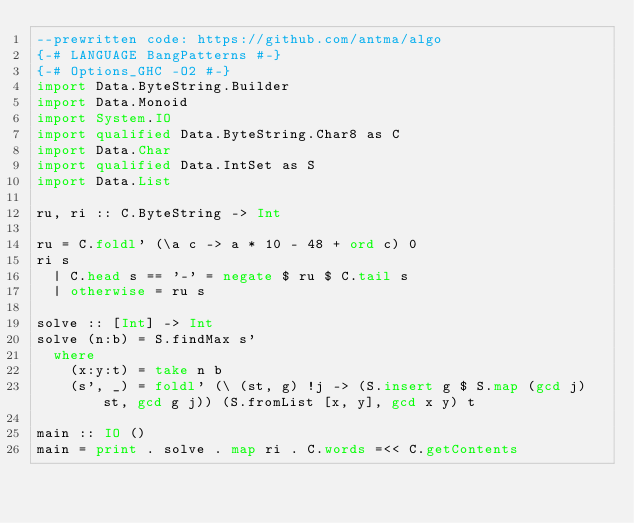<code> <loc_0><loc_0><loc_500><loc_500><_Haskell_>--prewritten code: https://github.com/antma/algo
{-# LANGUAGE BangPatterns #-}
{-# Options_GHC -O2 #-}
import Data.ByteString.Builder
import Data.Monoid
import System.IO
import qualified Data.ByteString.Char8 as C
import Data.Char
import qualified Data.IntSet as S
import Data.List

ru, ri :: C.ByteString -> Int

ru = C.foldl' (\a c -> a * 10 - 48 + ord c) 0
ri s
  | C.head s == '-' = negate $ ru $ C.tail s
  | otherwise = ru s

solve :: [Int] -> Int
solve (n:b) = S.findMax s'
  where
    (x:y:t) = take n b
    (s', _) = foldl' (\ (st, g) !j -> (S.insert g $ S.map (gcd j) st, gcd g j)) (S.fromList [x, y], gcd x y) t  

main :: IO ()
main = print . solve . map ri . C.words =<< C.getContents
</code> 